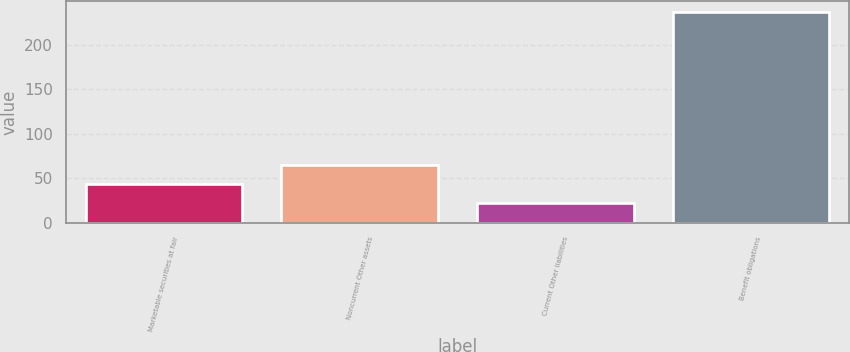Convert chart to OTSL. <chart><loc_0><loc_0><loc_500><loc_500><bar_chart><fcel>Marketable securities at fair<fcel>Noncurrent Other assets<fcel>Current Other liabilities<fcel>Benefit obligations<nl><fcel>43.5<fcel>65<fcel>22<fcel>237<nl></chart> 